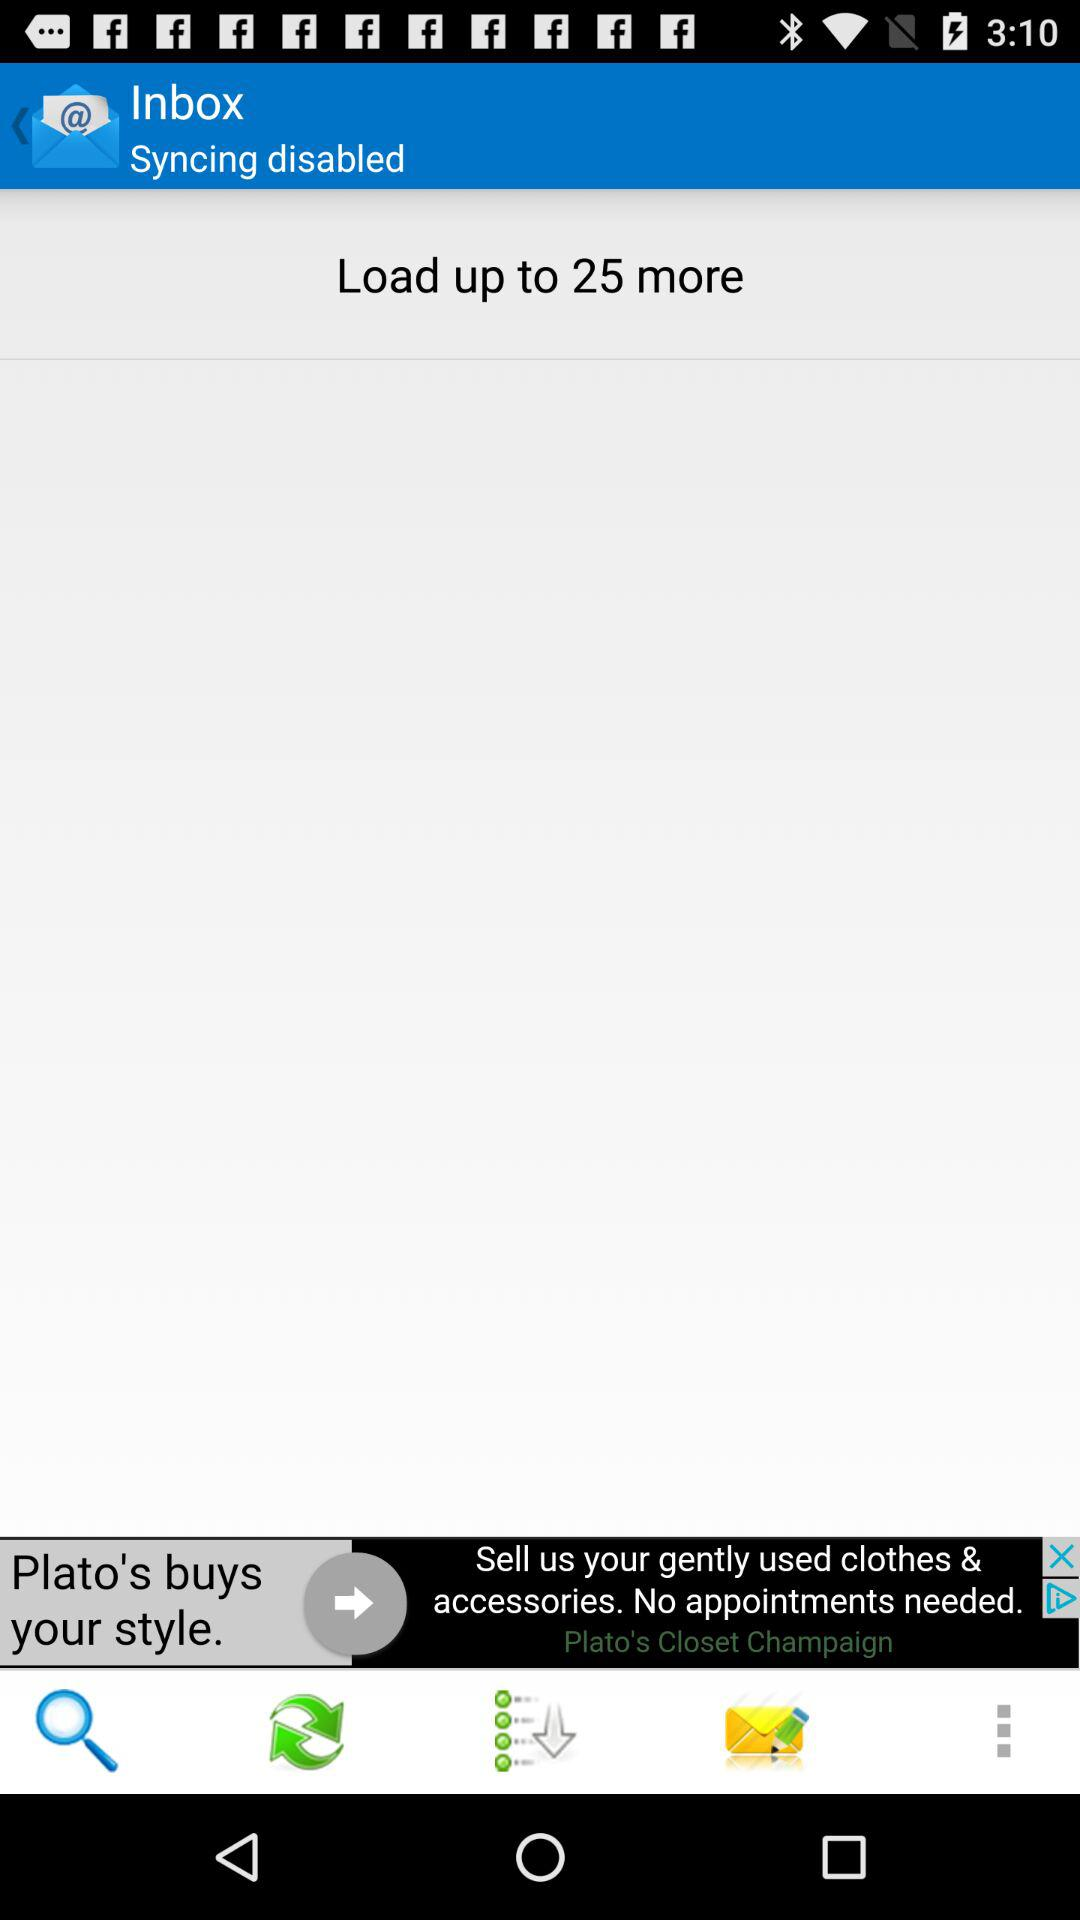How many more items can be loaded?
Answer the question using a single word or phrase. 25 